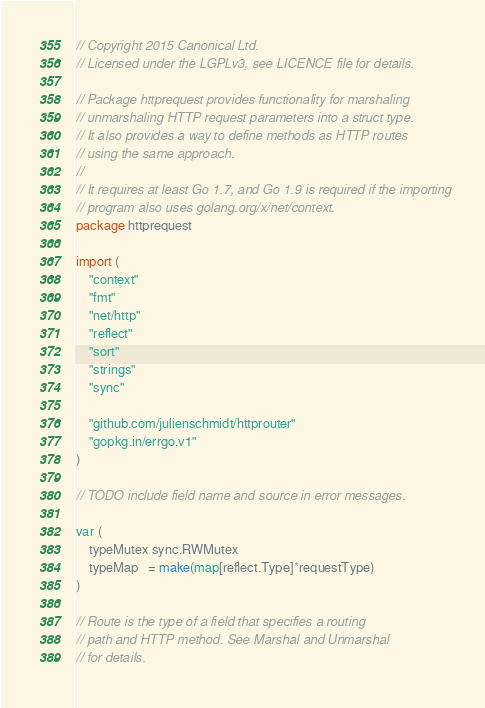Convert code to text. <code><loc_0><loc_0><loc_500><loc_500><_Go_>// Copyright 2015 Canonical Ltd.
// Licensed under the LGPLv3, see LICENCE file for details.

// Package httprequest provides functionality for marshaling
// unmarshaling HTTP request parameters into a struct type.
// It also provides a way to define methods as HTTP routes
// using the same approach.
//
// It requires at least Go 1.7, and Go 1.9 is required if the importing
// program also uses golang.org/x/net/context.
package httprequest

import (
	"context"
	"fmt"
	"net/http"
	"reflect"
	"sort"
	"strings"
	"sync"

	"github.com/julienschmidt/httprouter"
	"gopkg.in/errgo.v1"
)

// TODO include field name and source in error messages.

var (
	typeMutex sync.RWMutex
	typeMap   = make(map[reflect.Type]*requestType)
)

// Route is the type of a field that specifies a routing
// path and HTTP method. See Marshal and Unmarshal
// for details.</code> 